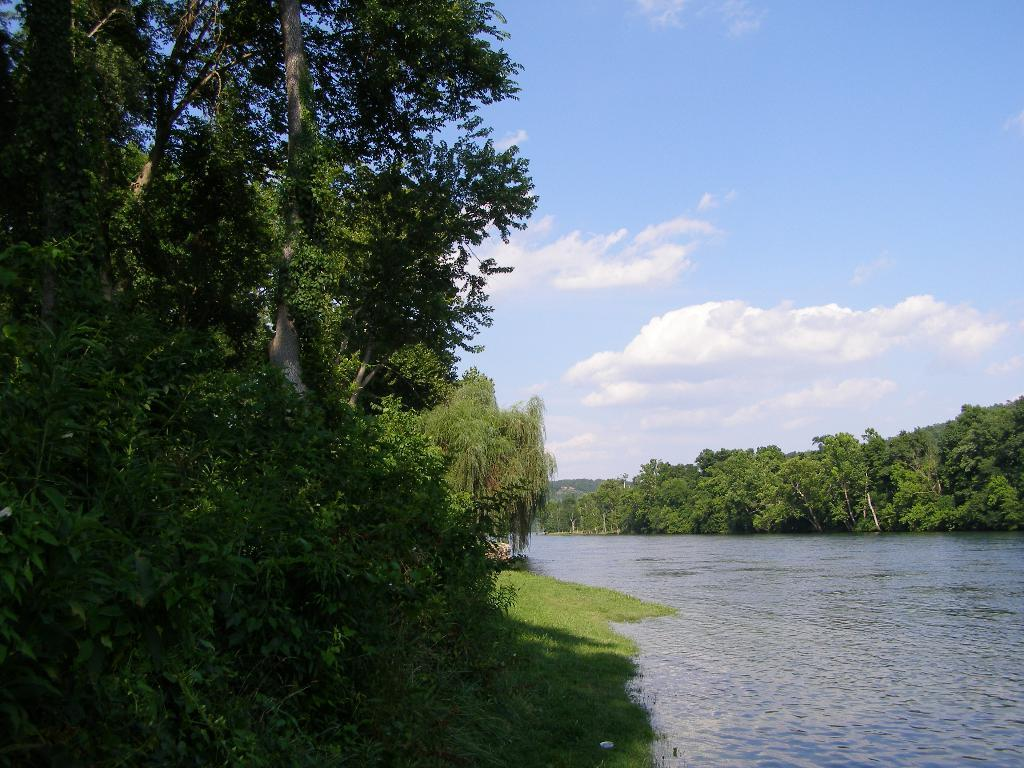What can be seen in the bottom right side of the image? There is water in the bottom right side of the image. What type of vegetation is present on both sides of the image? There is greenery on both sides of the image. What is visible in the background of the image? The sky is visible in the background of the image. How many pizzas are being served in the nest in the image? There is no nest or pizzas present in the image. What role does the porter play in the image? There is no porter present in the image. 